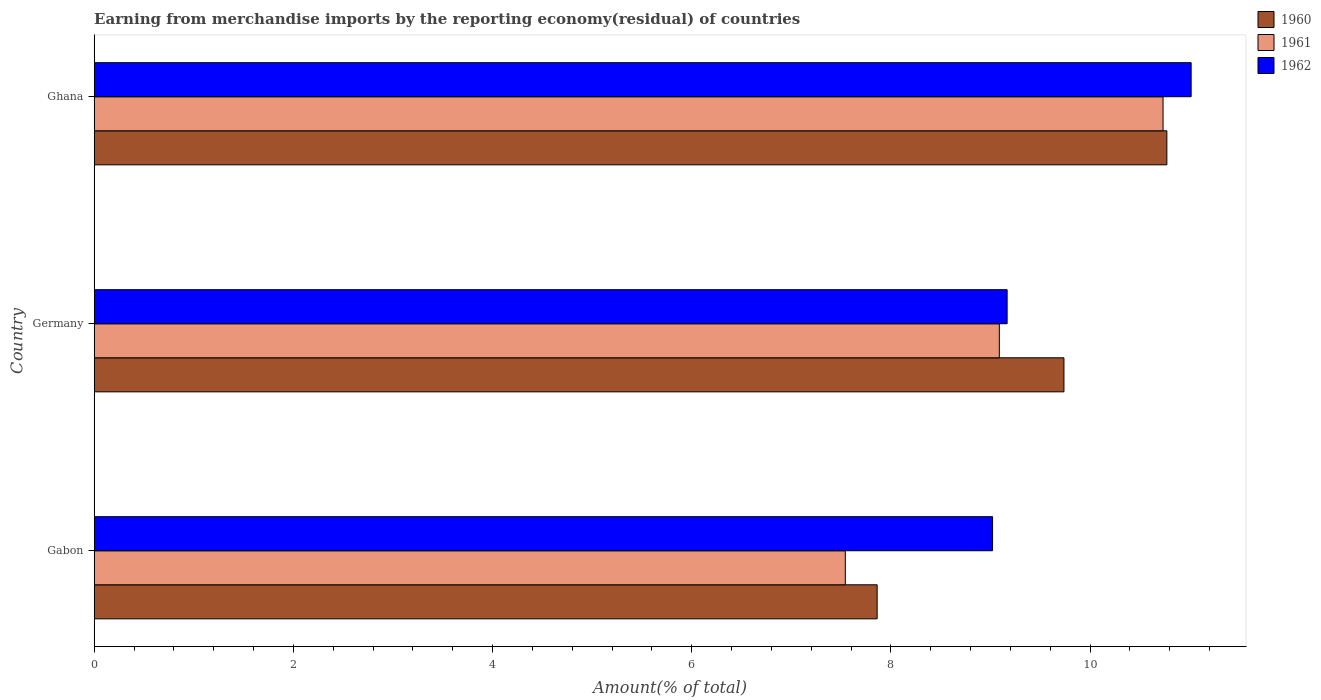How many different coloured bars are there?
Keep it short and to the point. 3. Are the number of bars per tick equal to the number of legend labels?
Make the answer very short. Yes. How many bars are there on the 3rd tick from the top?
Ensure brevity in your answer.  3. How many bars are there on the 1st tick from the bottom?
Make the answer very short. 3. What is the percentage of amount earned from merchandise imports in 1961 in Germany?
Keep it short and to the point. 9.09. Across all countries, what is the maximum percentage of amount earned from merchandise imports in 1960?
Make the answer very short. 10.77. Across all countries, what is the minimum percentage of amount earned from merchandise imports in 1960?
Your answer should be compact. 7.86. In which country was the percentage of amount earned from merchandise imports in 1960 minimum?
Provide a succinct answer. Gabon. What is the total percentage of amount earned from merchandise imports in 1962 in the graph?
Provide a succinct answer. 29.2. What is the difference between the percentage of amount earned from merchandise imports in 1962 in Germany and that in Ghana?
Your response must be concise. -1.85. What is the difference between the percentage of amount earned from merchandise imports in 1960 in Gabon and the percentage of amount earned from merchandise imports in 1961 in Germany?
Offer a terse response. -1.23. What is the average percentage of amount earned from merchandise imports in 1960 per country?
Offer a terse response. 9.46. What is the difference between the percentage of amount earned from merchandise imports in 1960 and percentage of amount earned from merchandise imports in 1962 in Gabon?
Your answer should be compact. -1.16. In how many countries, is the percentage of amount earned from merchandise imports in 1961 greater than 3.6 %?
Your answer should be very brief. 3. What is the ratio of the percentage of amount earned from merchandise imports in 1961 in Germany to that in Ghana?
Make the answer very short. 0.85. Is the percentage of amount earned from merchandise imports in 1960 in Germany less than that in Ghana?
Ensure brevity in your answer.  Yes. Is the difference between the percentage of amount earned from merchandise imports in 1960 in Gabon and Germany greater than the difference between the percentage of amount earned from merchandise imports in 1962 in Gabon and Germany?
Ensure brevity in your answer.  No. What is the difference between the highest and the second highest percentage of amount earned from merchandise imports in 1960?
Ensure brevity in your answer.  1.03. What is the difference between the highest and the lowest percentage of amount earned from merchandise imports in 1962?
Your answer should be very brief. 1.99. In how many countries, is the percentage of amount earned from merchandise imports in 1960 greater than the average percentage of amount earned from merchandise imports in 1960 taken over all countries?
Make the answer very short. 2. Is the sum of the percentage of amount earned from merchandise imports in 1961 in Gabon and Germany greater than the maximum percentage of amount earned from merchandise imports in 1962 across all countries?
Keep it short and to the point. Yes. What does the 3rd bar from the top in Gabon represents?
Provide a short and direct response. 1960. Is it the case that in every country, the sum of the percentage of amount earned from merchandise imports in 1960 and percentage of amount earned from merchandise imports in 1961 is greater than the percentage of amount earned from merchandise imports in 1962?
Your answer should be very brief. Yes. Are all the bars in the graph horizontal?
Your answer should be very brief. Yes. How many countries are there in the graph?
Your response must be concise. 3. Are the values on the major ticks of X-axis written in scientific E-notation?
Provide a short and direct response. No. Does the graph contain grids?
Make the answer very short. No. How many legend labels are there?
Your answer should be very brief. 3. What is the title of the graph?
Provide a succinct answer. Earning from merchandise imports by the reporting economy(residual) of countries. What is the label or title of the X-axis?
Offer a very short reply. Amount(% of total). What is the label or title of the Y-axis?
Make the answer very short. Country. What is the Amount(% of total) of 1960 in Gabon?
Offer a terse response. 7.86. What is the Amount(% of total) in 1961 in Gabon?
Your answer should be compact. 7.54. What is the Amount(% of total) of 1962 in Gabon?
Keep it short and to the point. 9.02. What is the Amount(% of total) of 1960 in Germany?
Provide a succinct answer. 9.74. What is the Amount(% of total) in 1961 in Germany?
Your response must be concise. 9.09. What is the Amount(% of total) of 1962 in Germany?
Give a very brief answer. 9.17. What is the Amount(% of total) in 1960 in Ghana?
Your answer should be very brief. 10.77. What is the Amount(% of total) in 1961 in Ghana?
Give a very brief answer. 10.73. What is the Amount(% of total) of 1962 in Ghana?
Your answer should be compact. 11.01. Across all countries, what is the maximum Amount(% of total) in 1960?
Your answer should be very brief. 10.77. Across all countries, what is the maximum Amount(% of total) of 1961?
Ensure brevity in your answer.  10.73. Across all countries, what is the maximum Amount(% of total) in 1962?
Give a very brief answer. 11.01. Across all countries, what is the minimum Amount(% of total) of 1960?
Offer a terse response. 7.86. Across all countries, what is the minimum Amount(% of total) in 1961?
Make the answer very short. 7.54. Across all countries, what is the minimum Amount(% of total) of 1962?
Offer a very short reply. 9.02. What is the total Amount(% of total) in 1960 in the graph?
Your answer should be compact. 28.37. What is the total Amount(% of total) of 1961 in the graph?
Make the answer very short. 27.36. What is the total Amount(% of total) in 1962 in the graph?
Ensure brevity in your answer.  29.2. What is the difference between the Amount(% of total) of 1960 in Gabon and that in Germany?
Ensure brevity in your answer.  -1.88. What is the difference between the Amount(% of total) in 1961 in Gabon and that in Germany?
Your answer should be compact. -1.55. What is the difference between the Amount(% of total) of 1962 in Gabon and that in Germany?
Ensure brevity in your answer.  -0.15. What is the difference between the Amount(% of total) in 1960 in Gabon and that in Ghana?
Provide a short and direct response. -2.91. What is the difference between the Amount(% of total) in 1961 in Gabon and that in Ghana?
Your response must be concise. -3.19. What is the difference between the Amount(% of total) of 1962 in Gabon and that in Ghana?
Your answer should be very brief. -1.99. What is the difference between the Amount(% of total) of 1960 in Germany and that in Ghana?
Your answer should be very brief. -1.03. What is the difference between the Amount(% of total) in 1961 in Germany and that in Ghana?
Provide a short and direct response. -1.64. What is the difference between the Amount(% of total) of 1962 in Germany and that in Ghana?
Your response must be concise. -1.85. What is the difference between the Amount(% of total) in 1960 in Gabon and the Amount(% of total) in 1961 in Germany?
Your response must be concise. -1.23. What is the difference between the Amount(% of total) in 1960 in Gabon and the Amount(% of total) in 1962 in Germany?
Give a very brief answer. -1.3. What is the difference between the Amount(% of total) in 1961 in Gabon and the Amount(% of total) in 1962 in Germany?
Your answer should be compact. -1.62. What is the difference between the Amount(% of total) of 1960 in Gabon and the Amount(% of total) of 1961 in Ghana?
Provide a succinct answer. -2.87. What is the difference between the Amount(% of total) in 1960 in Gabon and the Amount(% of total) in 1962 in Ghana?
Ensure brevity in your answer.  -3.15. What is the difference between the Amount(% of total) of 1961 in Gabon and the Amount(% of total) of 1962 in Ghana?
Offer a terse response. -3.47. What is the difference between the Amount(% of total) of 1960 in Germany and the Amount(% of total) of 1961 in Ghana?
Provide a short and direct response. -0.99. What is the difference between the Amount(% of total) in 1960 in Germany and the Amount(% of total) in 1962 in Ghana?
Ensure brevity in your answer.  -1.28. What is the difference between the Amount(% of total) of 1961 in Germany and the Amount(% of total) of 1962 in Ghana?
Offer a terse response. -1.93. What is the average Amount(% of total) in 1960 per country?
Your answer should be compact. 9.46. What is the average Amount(% of total) of 1961 per country?
Your answer should be very brief. 9.12. What is the average Amount(% of total) in 1962 per country?
Your answer should be very brief. 9.73. What is the difference between the Amount(% of total) of 1960 and Amount(% of total) of 1961 in Gabon?
Your answer should be very brief. 0.32. What is the difference between the Amount(% of total) in 1960 and Amount(% of total) in 1962 in Gabon?
Your answer should be very brief. -1.16. What is the difference between the Amount(% of total) of 1961 and Amount(% of total) of 1962 in Gabon?
Your response must be concise. -1.48. What is the difference between the Amount(% of total) of 1960 and Amount(% of total) of 1961 in Germany?
Keep it short and to the point. 0.65. What is the difference between the Amount(% of total) in 1960 and Amount(% of total) in 1962 in Germany?
Ensure brevity in your answer.  0.57. What is the difference between the Amount(% of total) in 1961 and Amount(% of total) in 1962 in Germany?
Your response must be concise. -0.08. What is the difference between the Amount(% of total) in 1960 and Amount(% of total) in 1961 in Ghana?
Give a very brief answer. 0.04. What is the difference between the Amount(% of total) in 1960 and Amount(% of total) in 1962 in Ghana?
Keep it short and to the point. -0.24. What is the difference between the Amount(% of total) in 1961 and Amount(% of total) in 1962 in Ghana?
Your answer should be very brief. -0.28. What is the ratio of the Amount(% of total) of 1960 in Gabon to that in Germany?
Provide a short and direct response. 0.81. What is the ratio of the Amount(% of total) of 1961 in Gabon to that in Germany?
Keep it short and to the point. 0.83. What is the ratio of the Amount(% of total) in 1962 in Gabon to that in Germany?
Provide a short and direct response. 0.98. What is the ratio of the Amount(% of total) of 1960 in Gabon to that in Ghana?
Offer a very short reply. 0.73. What is the ratio of the Amount(% of total) of 1961 in Gabon to that in Ghana?
Make the answer very short. 0.7. What is the ratio of the Amount(% of total) of 1962 in Gabon to that in Ghana?
Offer a very short reply. 0.82. What is the ratio of the Amount(% of total) of 1960 in Germany to that in Ghana?
Ensure brevity in your answer.  0.9. What is the ratio of the Amount(% of total) of 1961 in Germany to that in Ghana?
Your answer should be very brief. 0.85. What is the ratio of the Amount(% of total) in 1962 in Germany to that in Ghana?
Your answer should be very brief. 0.83. What is the difference between the highest and the second highest Amount(% of total) of 1960?
Your answer should be compact. 1.03. What is the difference between the highest and the second highest Amount(% of total) of 1961?
Provide a short and direct response. 1.64. What is the difference between the highest and the second highest Amount(% of total) of 1962?
Give a very brief answer. 1.85. What is the difference between the highest and the lowest Amount(% of total) of 1960?
Give a very brief answer. 2.91. What is the difference between the highest and the lowest Amount(% of total) of 1961?
Offer a terse response. 3.19. What is the difference between the highest and the lowest Amount(% of total) of 1962?
Make the answer very short. 1.99. 